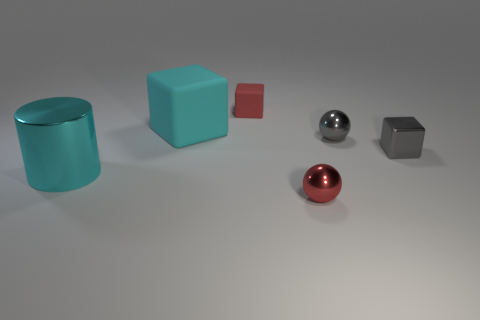Add 2 big gray spheres. How many objects exist? 8 Subtract all cylinders. How many objects are left? 5 Subtract all tiny gray shiny spheres. Subtract all tiny metal things. How many objects are left? 2 Add 6 tiny red rubber cubes. How many tiny red rubber cubes are left? 7 Add 4 gray metal blocks. How many gray metal blocks exist? 5 Subtract 0 yellow blocks. How many objects are left? 6 